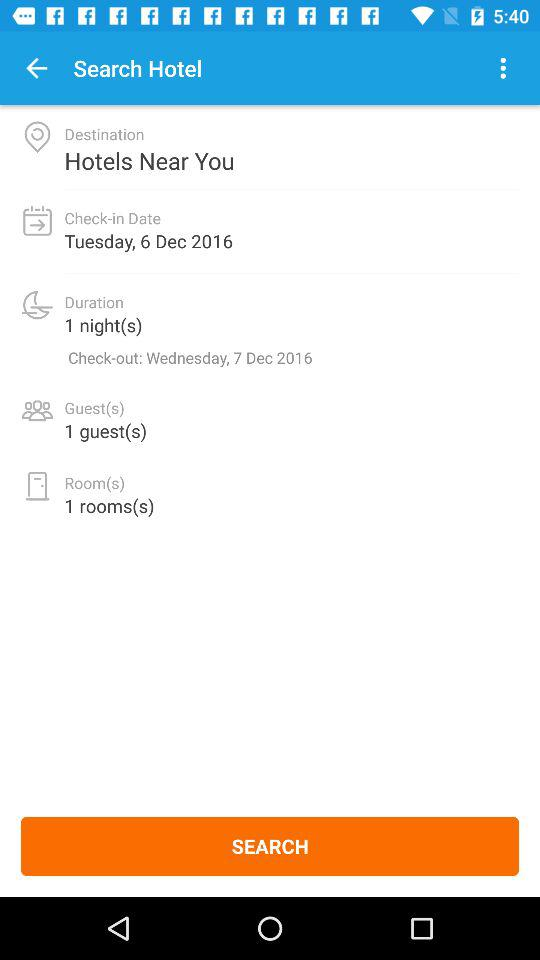How many rooms are being booked?
Answer the question using a single word or phrase. 1 